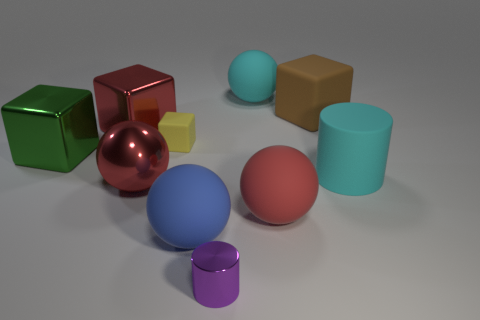Are there fewer objects that are on the left side of the big green object than gray spheres?
Provide a short and direct response. No. How many things are the same size as the yellow rubber cube?
Provide a succinct answer. 1. What shape is the large thing that is the same color as the matte cylinder?
Provide a short and direct response. Sphere. What shape is the small thing that is on the right side of the large rubber object that is to the left of the sphere behind the brown matte block?
Provide a short and direct response. Cylinder. There is a large cube that is to the right of the big red block; what color is it?
Offer a very short reply. Brown. How many things are either cubes that are on the right side of the red metal cube or rubber objects that are in front of the large green shiny cube?
Offer a very short reply. 5. What number of large shiny things have the same shape as the red rubber object?
Offer a very short reply. 1. What color is the matte block that is the same size as the blue sphere?
Offer a terse response. Brown. What is the color of the matte sphere that is to the left of the tiny thing that is in front of the big red metal thing in front of the large cyan rubber cylinder?
Provide a succinct answer. Blue. There is a brown block; is its size the same as the red thing that is behind the small rubber block?
Provide a short and direct response. Yes. 